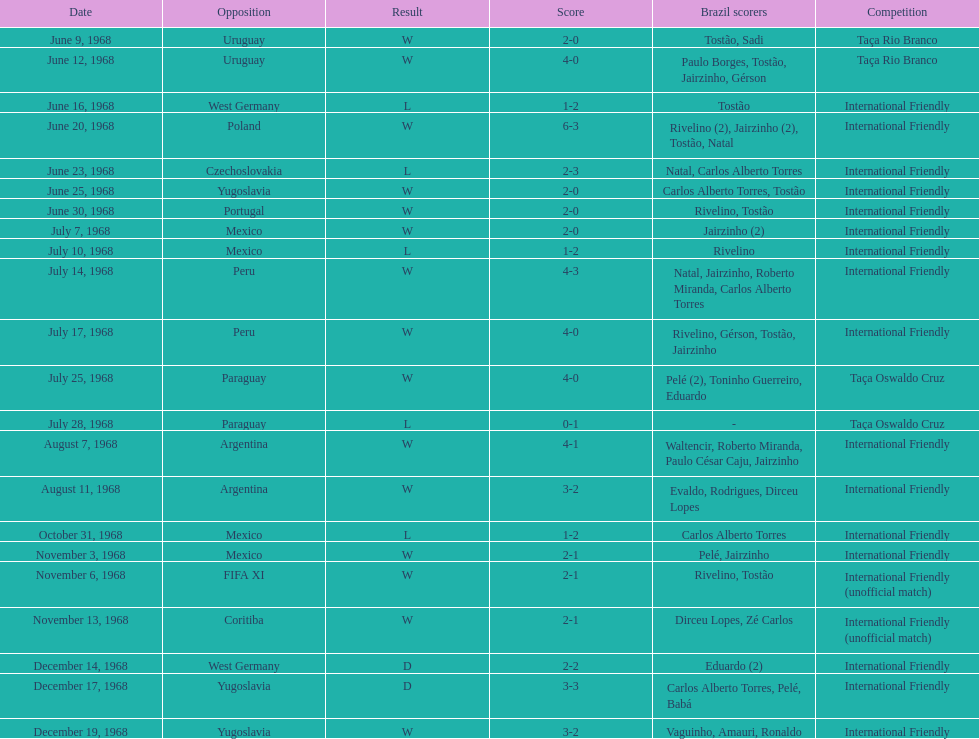Sum of successful outcomes 15. 